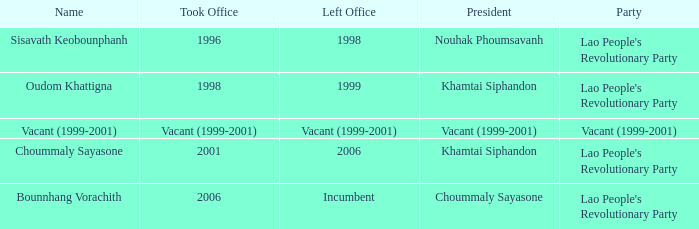Can you give me this table as a dict? {'header': ['Name', 'Took Office', 'Left Office', 'President', 'Party'], 'rows': [['Sisavath Keobounphanh', '1996', '1998', 'Nouhak Phoumsavanh', "Lao People's Revolutionary Party"], ['Oudom Khattigna', '1998', '1999', 'Khamtai Siphandon', "Lao People's Revolutionary Party"], ['Vacant (1999-2001)', 'Vacant (1999-2001)', 'Vacant (1999-2001)', 'Vacant (1999-2001)', 'Vacant (1999-2001)'], ['Choummaly Sayasone', '2001', '2006', 'Khamtai Siphandon', "Lao People's Revolutionary Party"], ['Bounnhang Vorachith', '2006', 'Incumbent', 'Choummaly Sayasone', "Lao People's Revolutionary Party"]]} What is Party, when Took Office is 1998? Lao People's Revolutionary Party. 